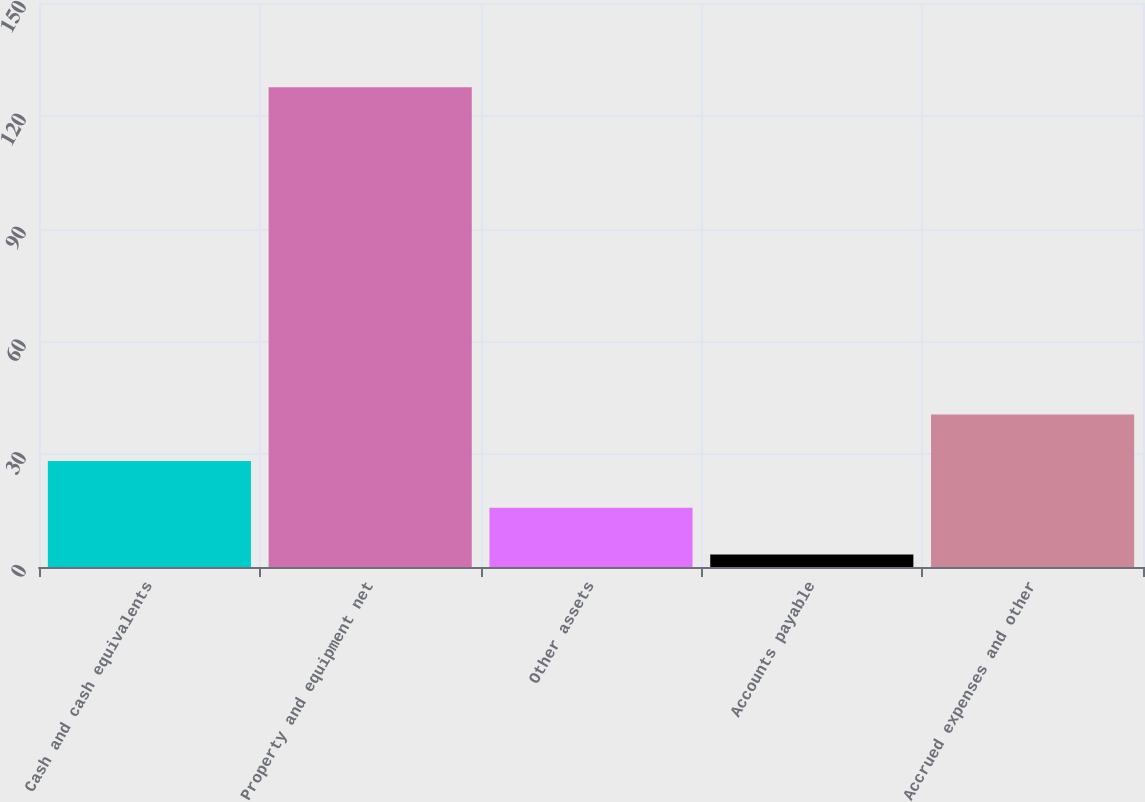<chart> <loc_0><loc_0><loc_500><loc_500><bar_chart><fcel>Cash and cash equivalents<fcel>Property and equipment net<fcel>Other assets<fcel>Accounts payable<fcel>Accrued expenses and other<nl><fcel>28.16<fcel>127.6<fcel>15.73<fcel>3.3<fcel>40.59<nl></chart> 